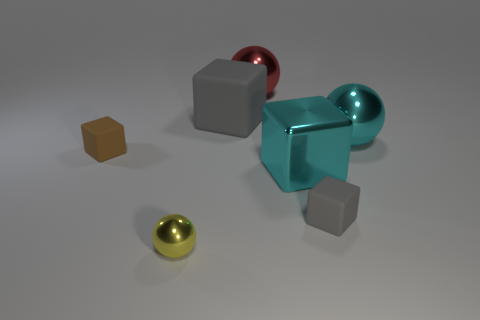What shape is the thing that is the same color as the large shiny cube?
Ensure brevity in your answer.  Sphere. What is the color of the small thing that is both behind the yellow metal thing and to the left of the red metallic thing?
Offer a terse response. Brown. How many things are either big cyan shiny things or brown rubber things?
Offer a terse response. 3. How many big things are either brown cylinders or yellow spheres?
Offer a very short reply. 0. Is there anything else that is the same color as the big metallic cube?
Give a very brief answer. Yes. There is a block that is both behind the large cyan cube and in front of the big gray block; how big is it?
Your answer should be very brief. Small. There is a small matte thing to the right of the yellow shiny object; is its color the same as the small thing left of the tiny yellow metal thing?
Provide a short and direct response. No. How many other objects are there of the same material as the cyan ball?
Ensure brevity in your answer.  3. There is a thing that is in front of the big gray cube and behind the small brown block; what is its shape?
Make the answer very short. Sphere. There is a metallic cube; does it have the same color as the matte cube that is behind the large cyan sphere?
Your response must be concise. No. 